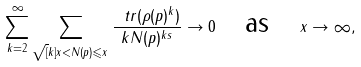Convert formula to latex. <formula><loc_0><loc_0><loc_500><loc_500>\sum _ { k = 2 } ^ { \infty } \sum _ { \sqrt { [ } k ] { x } < N ( p ) \leqslant x } \frac { \ t r ( \rho ( p ) ^ { k } ) } { k N ( p ) ^ { k s } } \to 0 \quad \text {as} \quad x \to \infty ,</formula> 